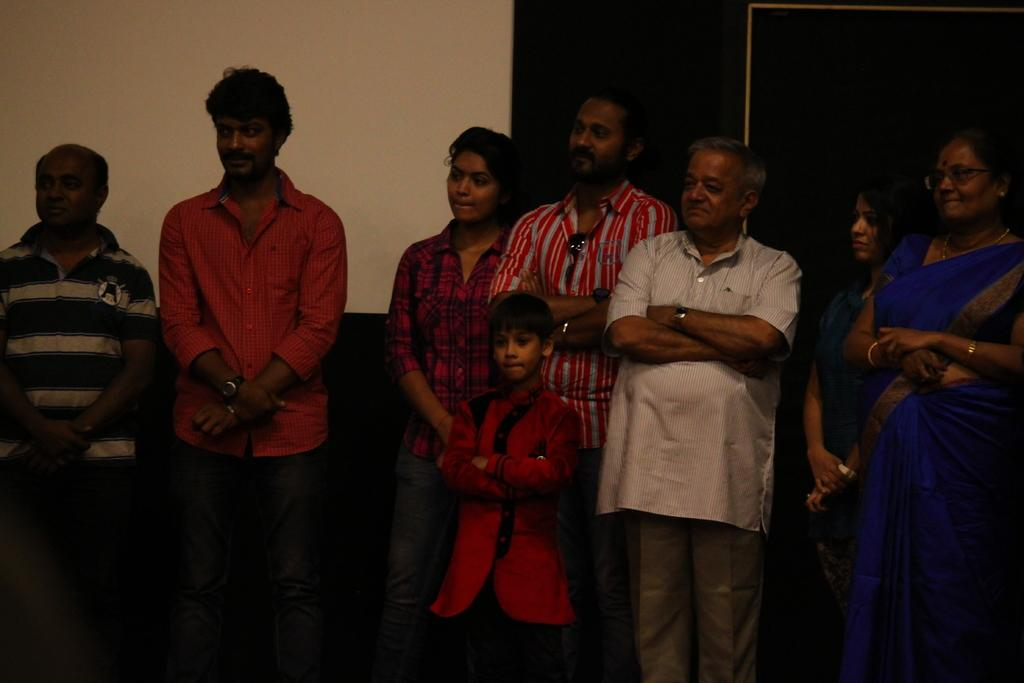How many people are in the image? There is a group of people in the image, but the exact number is not specified. What are the people in the image doing? The people are standing in the image. What can be seen in the background of the image? There is a wall and objects visible in the background of the image. What type of skate is being used by the people in the image? There is no skate present in the image; the people are standing. Can you tell me how many trucks are visible in the image? There is no truck present in the image; only a group of people, a wall, and objects are visible in the background. 